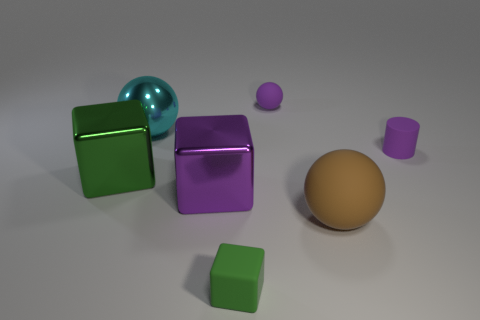How many other things are the same size as the metallic sphere?
Your answer should be compact. 3. There is a large object that is on the right side of the large green block and behind the large purple thing; what is its shape?
Provide a succinct answer. Sphere. Does the small green cube have the same material as the cyan sphere?
Keep it short and to the point. No. What number of other things are the same shape as the purple metal thing?
Make the answer very short. 2. What is the size of the cube that is in front of the large green metallic object and behind the large brown matte thing?
Your answer should be compact. Large. How many matte things are either small blue blocks or large brown objects?
Make the answer very short. 1. There is a large cyan shiny object that is in front of the small matte sphere; is it the same shape as the large object that is to the right of the purple rubber ball?
Your response must be concise. Yes. Are there any large yellow cubes that have the same material as the small green object?
Your answer should be compact. No. The metallic ball has what color?
Keep it short and to the point. Cyan. What size is the metallic cube that is on the right side of the large green metallic object?
Give a very brief answer. Large. 